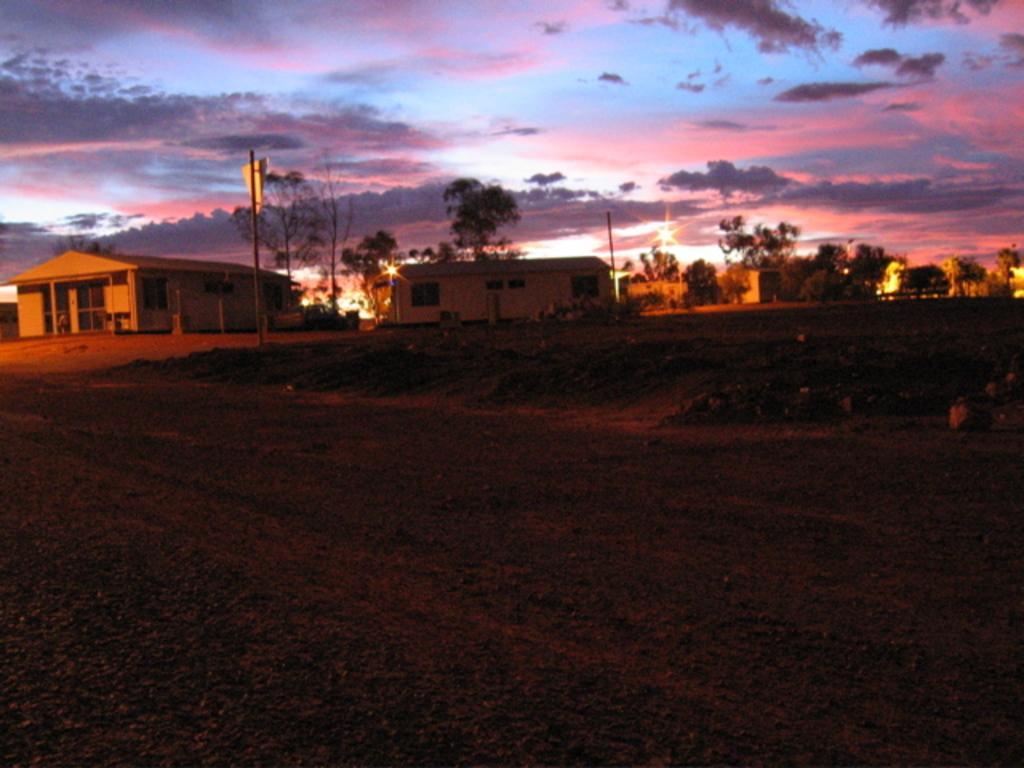In one or two sentences, can you explain what this image depicts? In the picture we can see the muddy surface and far away from it, we can see the pole and behind it, we can see few houses, trees and the sky with clouds. 